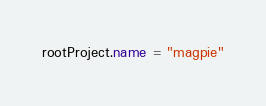Convert code to text. <code><loc_0><loc_0><loc_500><loc_500><_Kotlin_>rootProject.name = "magpie"

</code> 